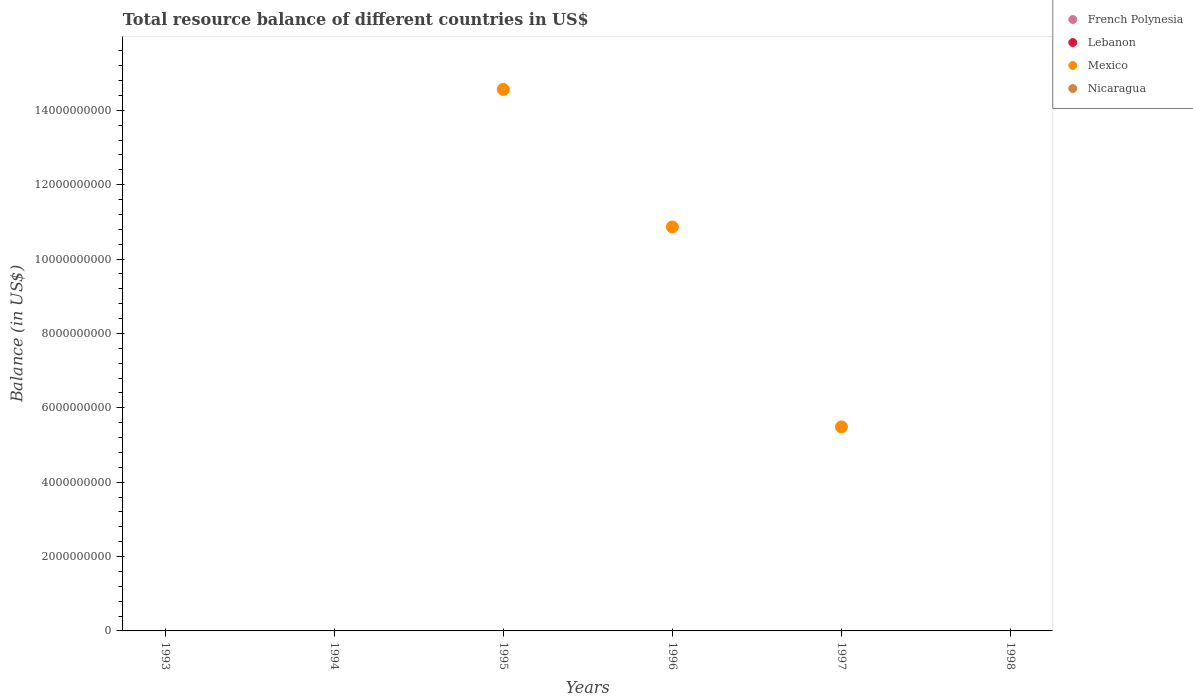How many different coloured dotlines are there?
Provide a short and direct response. 1. What is the total resource balance in Mexico in 1997?
Your response must be concise. 5.49e+09. In which year was the total resource balance in Mexico maximum?
Provide a succinct answer. 1995. What is the total total resource balance in French Polynesia in the graph?
Your answer should be compact. 0. What is the difference between the highest and the second highest total resource balance in Mexico?
Give a very brief answer. 3.70e+09. What is the difference between the highest and the lowest total resource balance in Mexico?
Offer a very short reply. 1.46e+1. Is it the case that in every year, the sum of the total resource balance in Lebanon and total resource balance in Mexico  is greater than the total resource balance in French Polynesia?
Provide a succinct answer. No. Is the total resource balance in Lebanon strictly less than the total resource balance in Nicaragua over the years?
Give a very brief answer. Yes. How many dotlines are there?
Offer a very short reply. 1. Where does the legend appear in the graph?
Ensure brevity in your answer.  Top right. How many legend labels are there?
Your answer should be very brief. 4. How are the legend labels stacked?
Your answer should be compact. Vertical. What is the title of the graph?
Offer a very short reply. Total resource balance of different countries in US$. What is the label or title of the X-axis?
Ensure brevity in your answer.  Years. What is the label or title of the Y-axis?
Keep it short and to the point. Balance (in US$). What is the Balance (in US$) of Lebanon in 1993?
Provide a short and direct response. 0. What is the Balance (in US$) in Nicaragua in 1993?
Offer a very short reply. 0. What is the Balance (in US$) in French Polynesia in 1994?
Provide a succinct answer. 0. What is the Balance (in US$) in Lebanon in 1994?
Make the answer very short. 0. What is the Balance (in US$) in Mexico in 1995?
Your response must be concise. 1.46e+1. What is the Balance (in US$) of Lebanon in 1996?
Your answer should be compact. 0. What is the Balance (in US$) of Mexico in 1996?
Provide a succinct answer. 1.09e+1. What is the Balance (in US$) in French Polynesia in 1997?
Your answer should be compact. 0. What is the Balance (in US$) in Lebanon in 1997?
Offer a terse response. 0. What is the Balance (in US$) of Mexico in 1997?
Make the answer very short. 5.49e+09. What is the Balance (in US$) of Nicaragua in 1997?
Your answer should be compact. 0. What is the Balance (in US$) in Lebanon in 1998?
Your answer should be compact. 0. What is the Balance (in US$) of Mexico in 1998?
Keep it short and to the point. 0. Across all years, what is the maximum Balance (in US$) in Mexico?
Ensure brevity in your answer.  1.46e+1. Across all years, what is the minimum Balance (in US$) in Mexico?
Ensure brevity in your answer.  0. What is the total Balance (in US$) in Mexico in the graph?
Offer a terse response. 3.09e+1. What is the difference between the Balance (in US$) in Mexico in 1995 and that in 1996?
Ensure brevity in your answer.  3.70e+09. What is the difference between the Balance (in US$) in Mexico in 1995 and that in 1997?
Offer a very short reply. 9.07e+09. What is the difference between the Balance (in US$) in Mexico in 1996 and that in 1997?
Offer a very short reply. 5.37e+09. What is the average Balance (in US$) in Mexico per year?
Offer a very short reply. 5.15e+09. What is the ratio of the Balance (in US$) of Mexico in 1995 to that in 1996?
Your answer should be very brief. 1.34. What is the ratio of the Balance (in US$) of Mexico in 1995 to that in 1997?
Ensure brevity in your answer.  2.65. What is the ratio of the Balance (in US$) in Mexico in 1996 to that in 1997?
Ensure brevity in your answer.  1.98. What is the difference between the highest and the second highest Balance (in US$) of Mexico?
Provide a short and direct response. 3.70e+09. What is the difference between the highest and the lowest Balance (in US$) of Mexico?
Ensure brevity in your answer.  1.46e+1. 